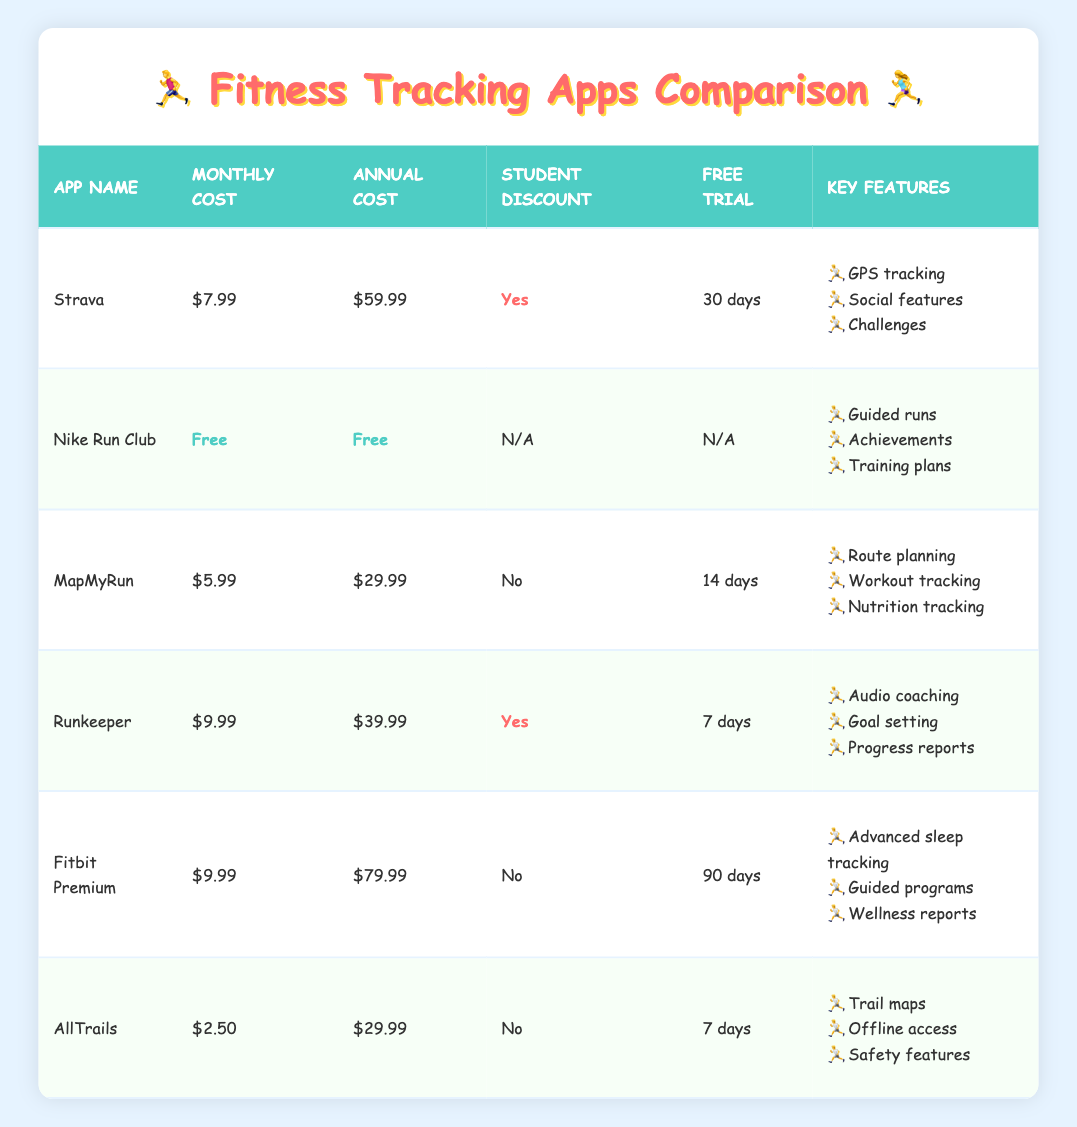What is the monthly cost of Strava? The monthly cost for Strava is clearly listed in the table under the monthly cost column. It shows the value of 7.99.
Answer: 7.99 Which app has the longest free trial? To identify the app with the longest free trial, we can compare the free trial days for each app listed in the table. Fitbit Premium offers 90 days, which is longer than all other options.
Answer: 90 days Is there a student discount available for MapMyRun? We can check the student discount column for MapMyRun. The entry shows "No," indicating that there is no student discount available.
Answer: No What is the total annual cost of using Strava and Runkeeper? We first find the annual costs of both apps in the annual cost column. Strava costs 59.99, and Runkeeper costs 39.99. We add these values together: 59.99 + 39.99 = 99.98.
Answer: 99.98 Which app has the cheapest monthly cost? By reviewing the monthly cost column for all the apps, we find that AllTrails has the lowest value of 2.50, among all the listed apps in the table.
Answer: 2.50 Are there any apps that offer a free monthly subscription? We can look through the monthly cost column to see if any apps list "Free." Here, Nike Run Club shows both the monthly and annual cost as free, confirming it's available without subscription costs.
Answer: Yes What is the average monthly cost of all the paid apps? First, we identify all the apps that have a non-zero monthly cost: Strava (7.99), MapMyRun (5.99), Runkeeper (9.99), Fitbit Premium (9.99), and AllTrails (2.50). We sum these costs: 7.99 + 5.99 + 9.99 + 9.99 + 2.50 = 36.46. Then we divide that total by the number of apps (5): 36.46 / 5 = 7.292.
Answer: 7.29 Is there any app that provides audio coaching as a feature? By checking the key features of each app, we see that Runkeeper lists "Audio coaching" as one of its key features, confirming its availability.
Answer: Yes What is the difference in annual costs between FitBit Premium and MapMyRun? From the table, we see that Fitbit Premium has an annual cost of 79.99, while MapMyRun has an annual cost of 29.99. We calculate the difference: 79.99 - 29.99 = 50.00.
Answer: 50.00 